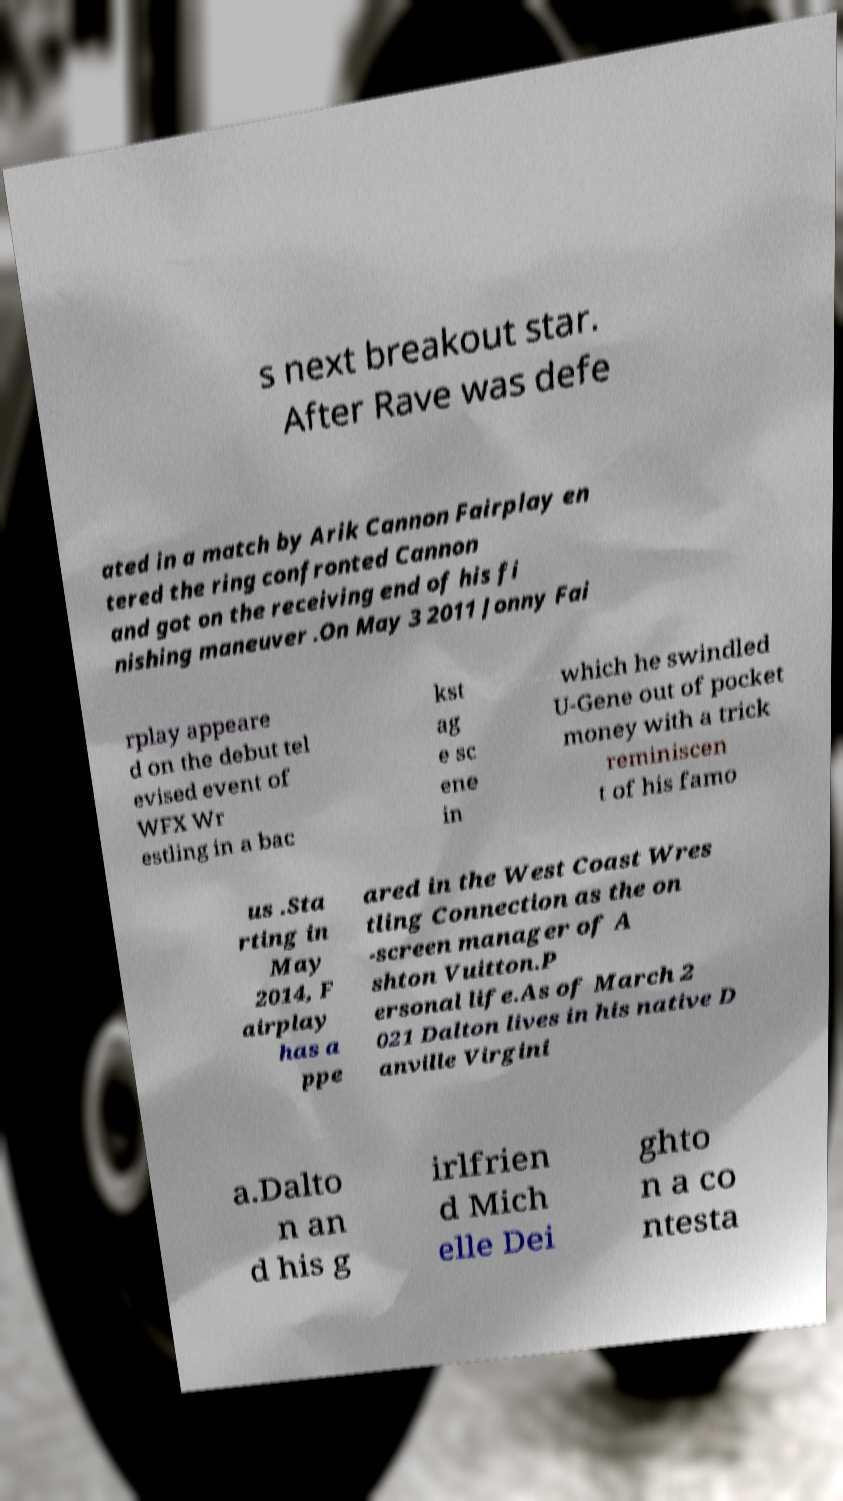What messages or text are displayed in this image? I need them in a readable, typed format. s next breakout star. After Rave was defe ated in a match by Arik Cannon Fairplay en tered the ring confronted Cannon and got on the receiving end of his fi nishing maneuver .On May 3 2011 Jonny Fai rplay appeare d on the debut tel evised event of WFX Wr estling in a bac kst ag e sc ene in which he swindled U-Gene out of pocket money with a trick reminiscen t of his famo us .Sta rting in May 2014, F airplay has a ppe ared in the West Coast Wres tling Connection as the on -screen manager of A shton Vuitton.P ersonal life.As of March 2 021 Dalton lives in his native D anville Virgini a.Dalto n an d his g irlfrien d Mich elle Dei ghto n a co ntesta 